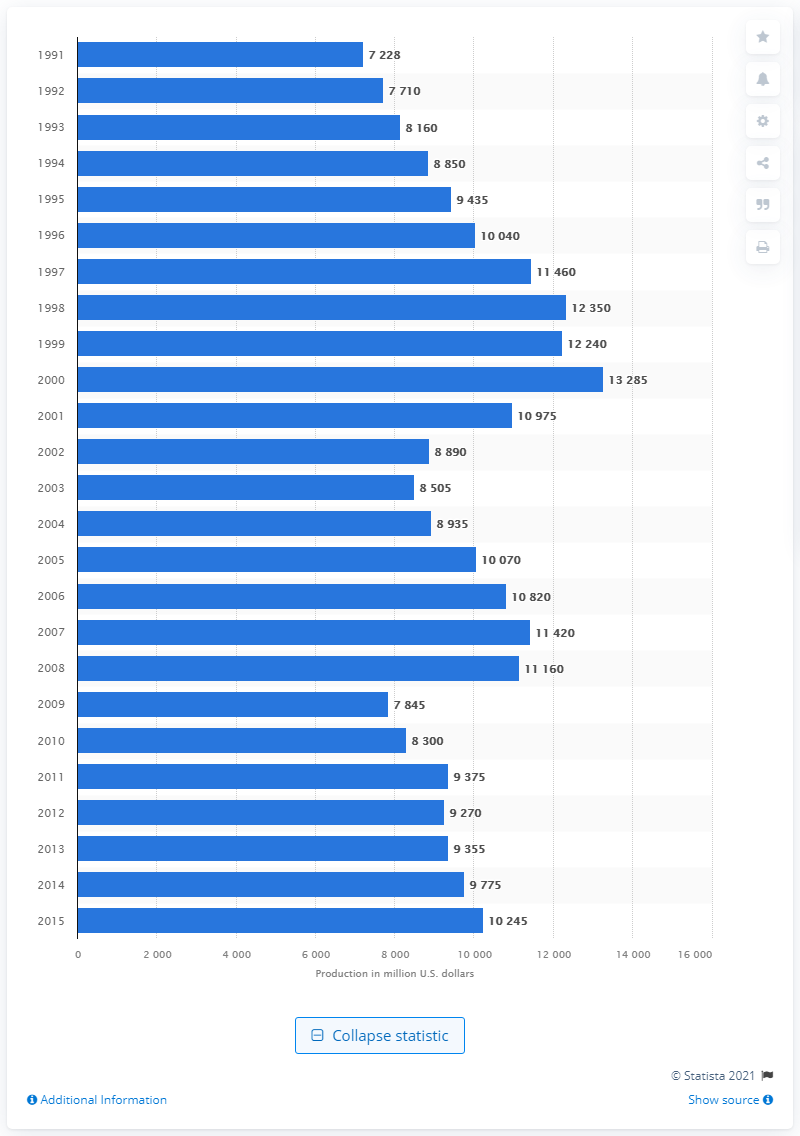Mention a couple of crucial points in this snapshot. The total production value of office furniture manufacturers in 2015 was 10,245. 